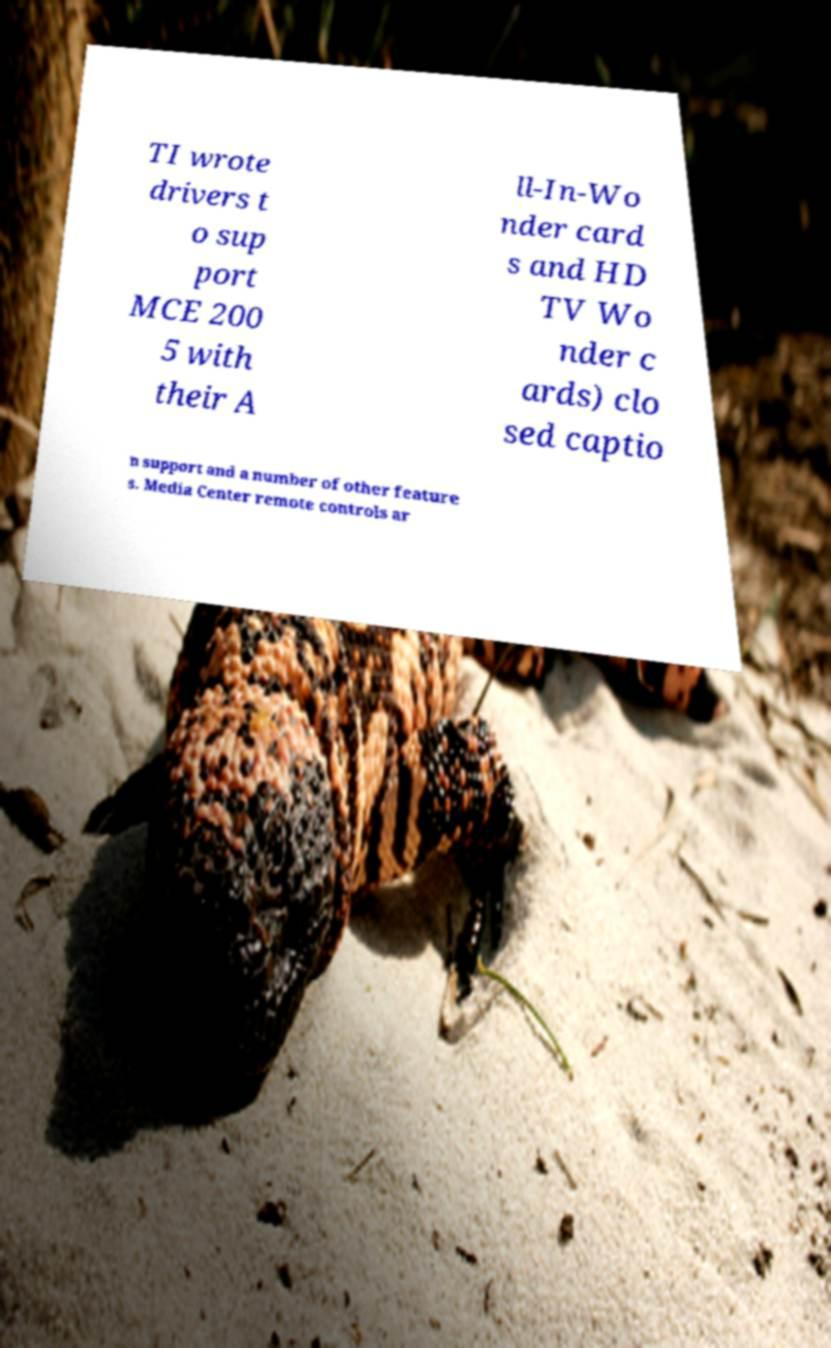Could you assist in decoding the text presented in this image and type it out clearly? TI wrote drivers t o sup port MCE 200 5 with their A ll-In-Wo nder card s and HD TV Wo nder c ards) clo sed captio n support and a number of other feature s. Media Center remote controls ar 